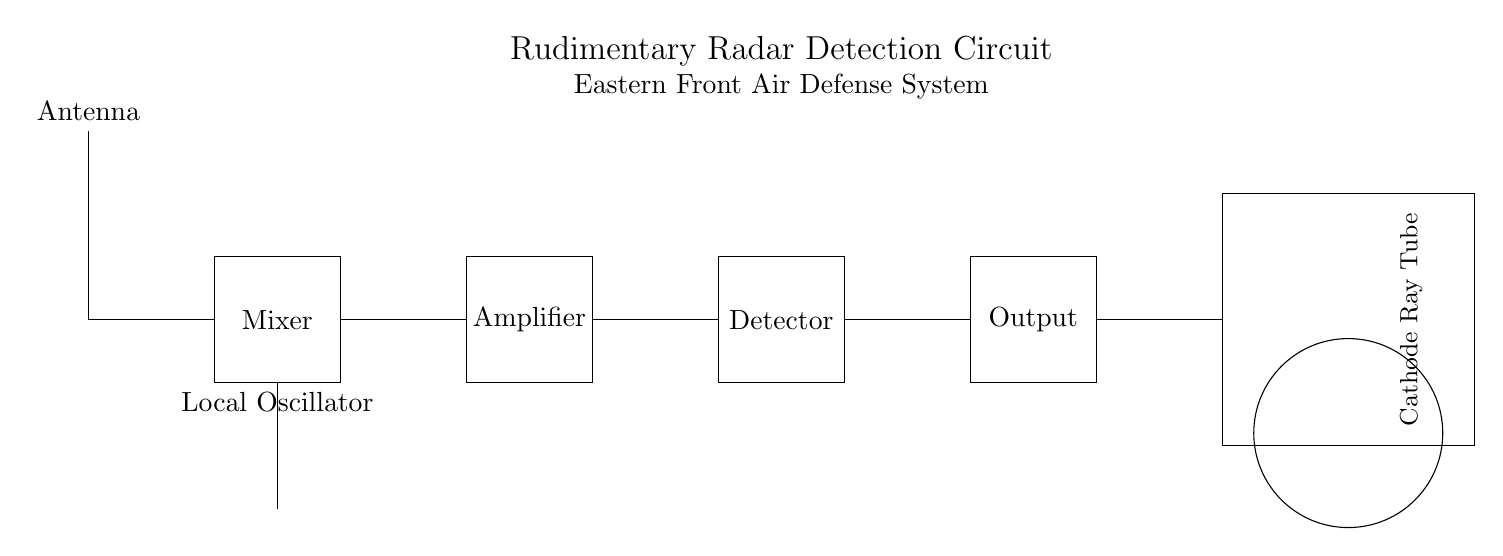What is the first component in the circuit? The first component is the antenna, which is depicted at the top of the circuit diagram. It is the element responsible for receiving radio waves.
Answer: Antenna What component follows the transmission line? The component that follows the transmission line is the mixer, as it is drawn directly after it and is crucial for combining signals.
Answer: Mixer What is the function of the local oscillator in the circuit? The local oscillator generates a reference frequency that is mixed with the incoming RF signal by the mixer. This function is essential for down-converting the signal for further processing.
Answer: Frequency generation How many main stages are there in the circuit? The main stages in the circuit consist of the mixer, amplifier, detector, and output stages, totaling four main stages necessary for radar signal processing.
Answer: Four What is the purpose of the amplifier in this radar circuit? The amplifier increases the power of the received signals, ensuring that they are strong enough for effective detection by the subsequent components in the circuit.
Answer: Signal amplification What type of display is used at the output of this circuit? The type of display used at the output is a cathode ray tube, which is common for visualizing radar signals in a comprehensible manner.
Answer: Cathode Ray Tube 